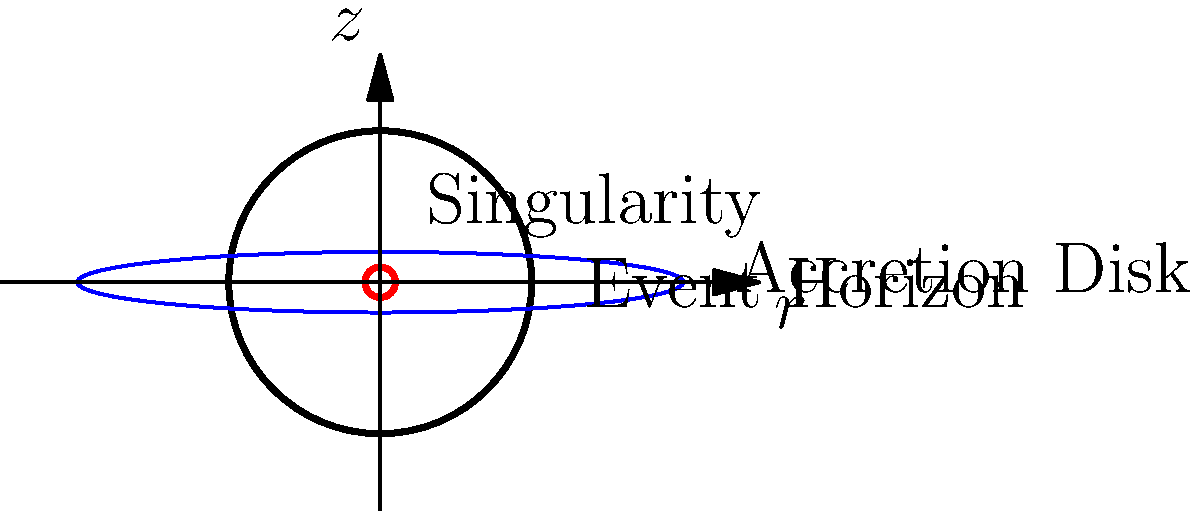In the cross-sectional diagram of a black hole shown above, what fundamental physical principle explains why no information can escape from within the event horizon, and how does this relate to the curvature of spacetime near the singularity? To answer this question, we need to consider several key aspects of black hole physics:

1. Event Horizon: The event horizon is a boundary in spacetime beyond which events cannot affect an outside observer. It's represented by the black circle in the diagram.

2. Singularity: The central point where the mass of the black hole is concentrated, represented by the red circle in the diagram.

3. Spacetime curvature: Near the singularity, spacetime is extremely curved due to the intense gravitational field.

4. Escape velocity: As we approach the event horizon, the escape velocity approaches the speed of light.

5. Special Relativity: According to Einstein's theory, nothing can travel faster than the speed of light in vacuum.

6. General Relativity: This theory describes gravity as a consequence of the curvature of spacetime.

The fundamental principle at work here is the combination of General Relativity and the speed of light limit from Special Relativity:

1. General Relativity tells us that the intense mass of the black hole curves spacetime severely.

2. This curvature becomes so extreme at the event horizon that the escape velocity reaches the speed of light.

3. Special Relativity prohibits any information or matter from traveling faster than light.

4. Therefore, once anything crosses the event horizon, it cannot escape, as it would need to travel faster than light to do so.

5. The extreme curvature near the singularity (represented by the tight red circle in the diagram) further ensures that all paths lead inevitably towards the center, reinforcing the impossibility of escape.

This principle explains why no information can escape from within the event horizon and relates directly to the extreme spacetime curvature near the singularity.
Answer: General Relativity's spacetime curvature combined with Special Relativity's light-speed limit prevents information escape beyond the event horizon. 